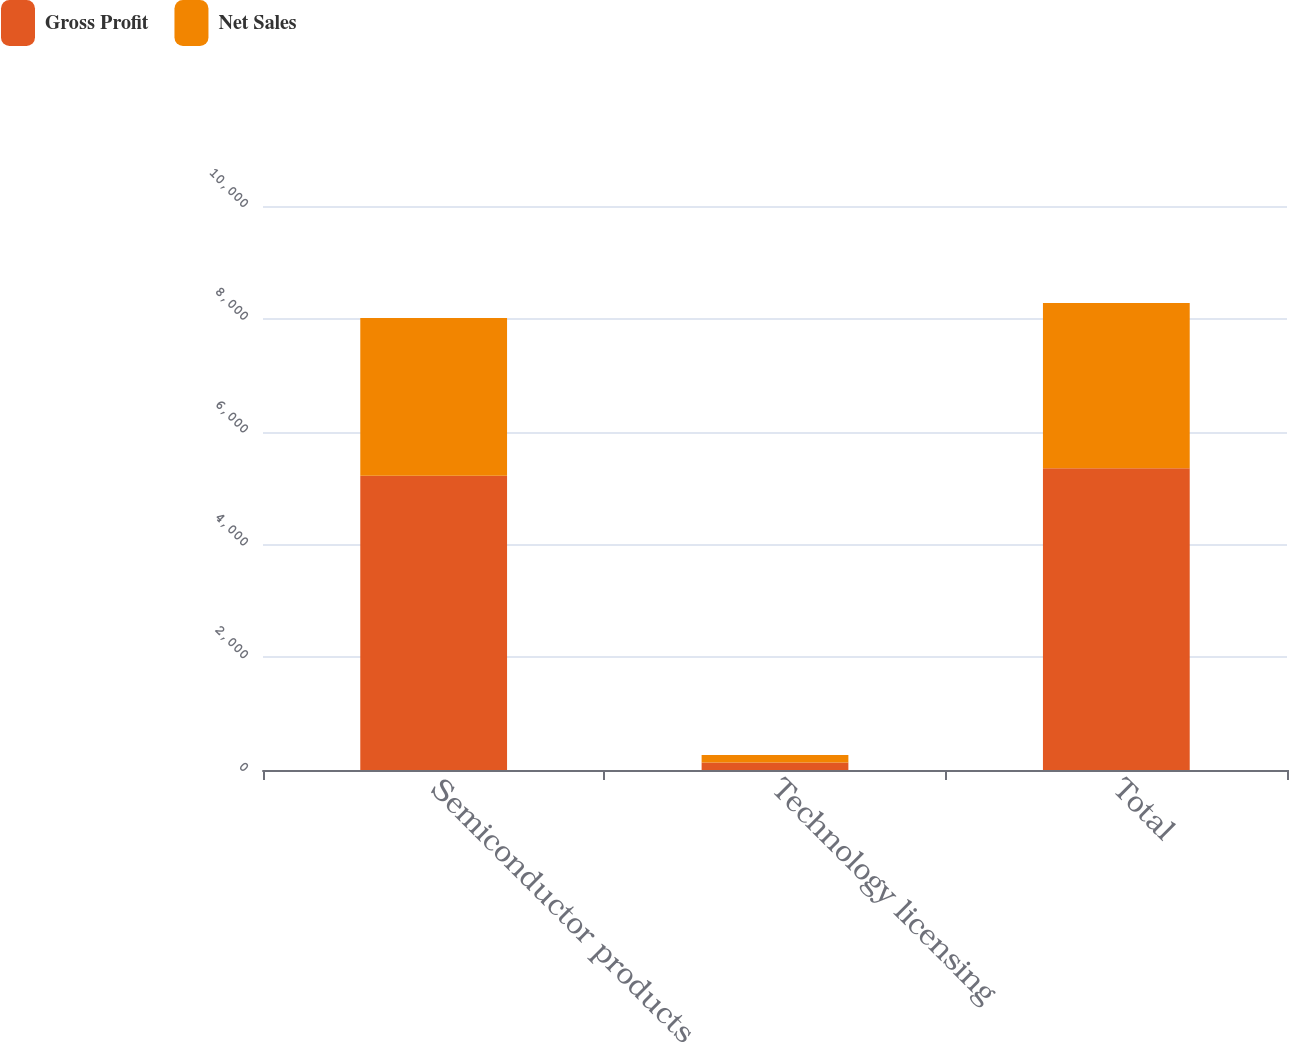Convert chart to OTSL. <chart><loc_0><loc_0><loc_500><loc_500><stacked_bar_chart><ecel><fcel>Semiconductor products<fcel>Technology licensing<fcel>Total<nl><fcel>Gross Profit<fcel>5217.1<fcel>132.4<fcel>5349.5<nl><fcel>Net Sales<fcel>2798.9<fcel>132.4<fcel>2931.3<nl></chart> 